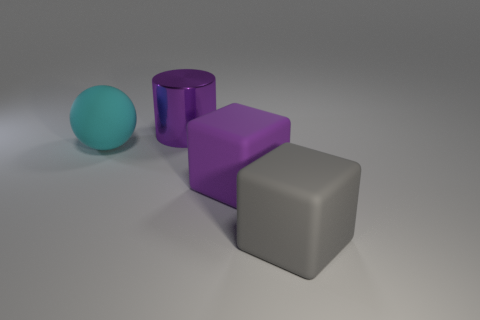Add 3 gray metal cylinders. How many objects exist? 7 Subtract all balls. How many objects are left? 3 Subtract all big purple shiny cylinders. Subtract all big green cylinders. How many objects are left? 3 Add 4 cyan spheres. How many cyan spheres are left? 5 Add 2 big gray matte blocks. How many big gray matte blocks exist? 3 Subtract 0 green balls. How many objects are left? 4 